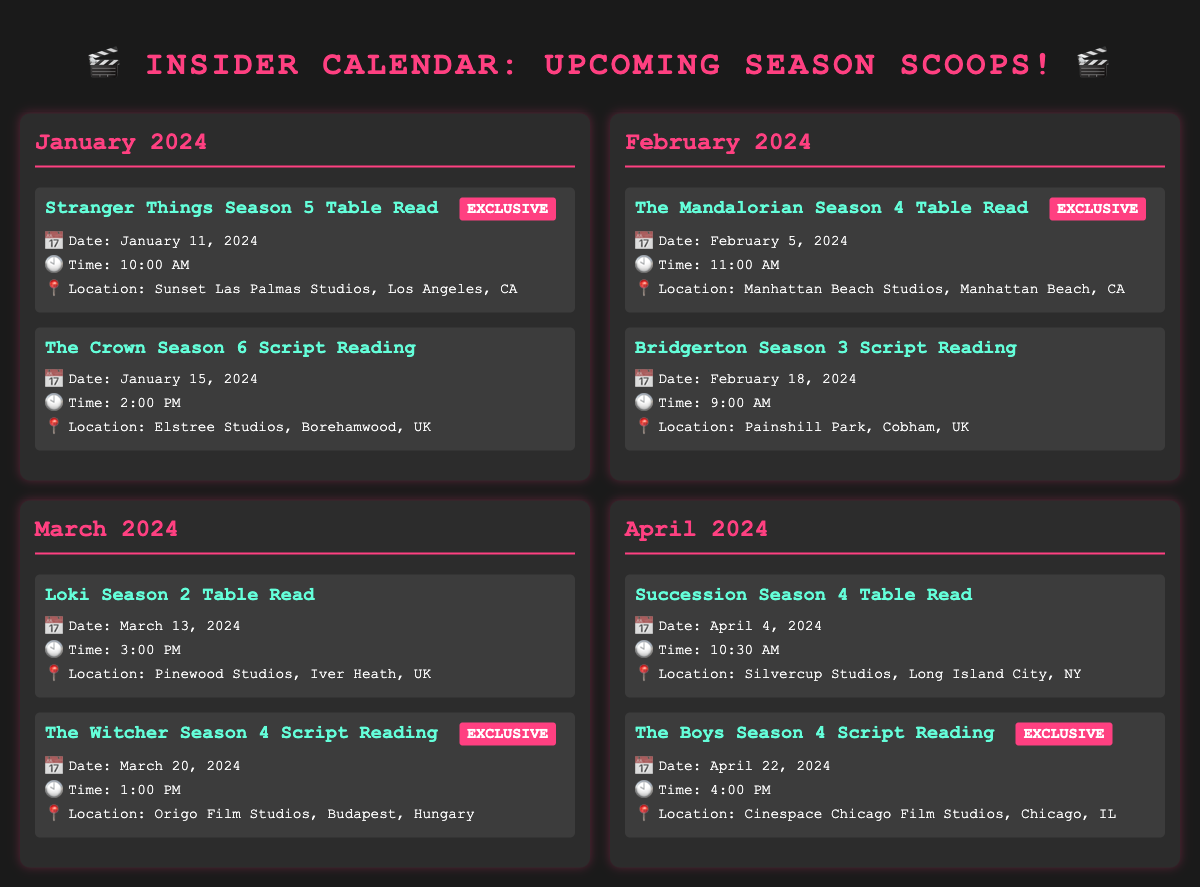what is the date of the Stranger Things Season 5 Table Read? The date is mentioned in the event details for Stranger Things Season 5, which states January 11, 2024.
Answer: January 11, 2024 what time is The Crown Season 6 Script Reading? The time is specified under The Crown Season 6 event as 2:00 PM.
Answer: 2:00 PM which event has an exclusive tag in February? The exclusive event in February is The Mandalorian Season 4 Table Read which is highlighted in the document.
Answer: The Mandalorian Season 4 Table Read how many script readings are scheduled in March? There are two scheduled events in March: Loki Season 2 Table Read and The Witcher Season 4 Script Reading.
Answer: 2 what is the location for The Boys Season 4 Script Reading? The document states that The Boys Season 4 Script Reading is at Cinespace Chicago Film Studios, Chicago, IL.
Answer: Cinespace Chicago Film Studios, Chicago, IL which month's events start with a table read? The events in January start with a Table Read for Stranger Things Season 5.
Answer: January what is the last event listed in this calendar? The last event in the calendar is The Boys Season 4 Script Reading on April 22, 2024.
Answer: The Boys Season 4 Script Reading what location hosts the event for The Witcher Season 4 Script Reading? The location for The Witcher Season 4 Script Reading is mentioned as Origo Film Studios, Budapest, Hungary.
Answer: Origo Film Studios, Budapest, Hungary 